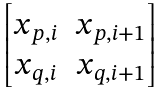<formula> <loc_0><loc_0><loc_500><loc_500>\begin{bmatrix} x _ { p , i } & x _ { p , i + 1 } \\ x _ { q , i } & x _ { q , i + 1 } \end{bmatrix}</formula> 